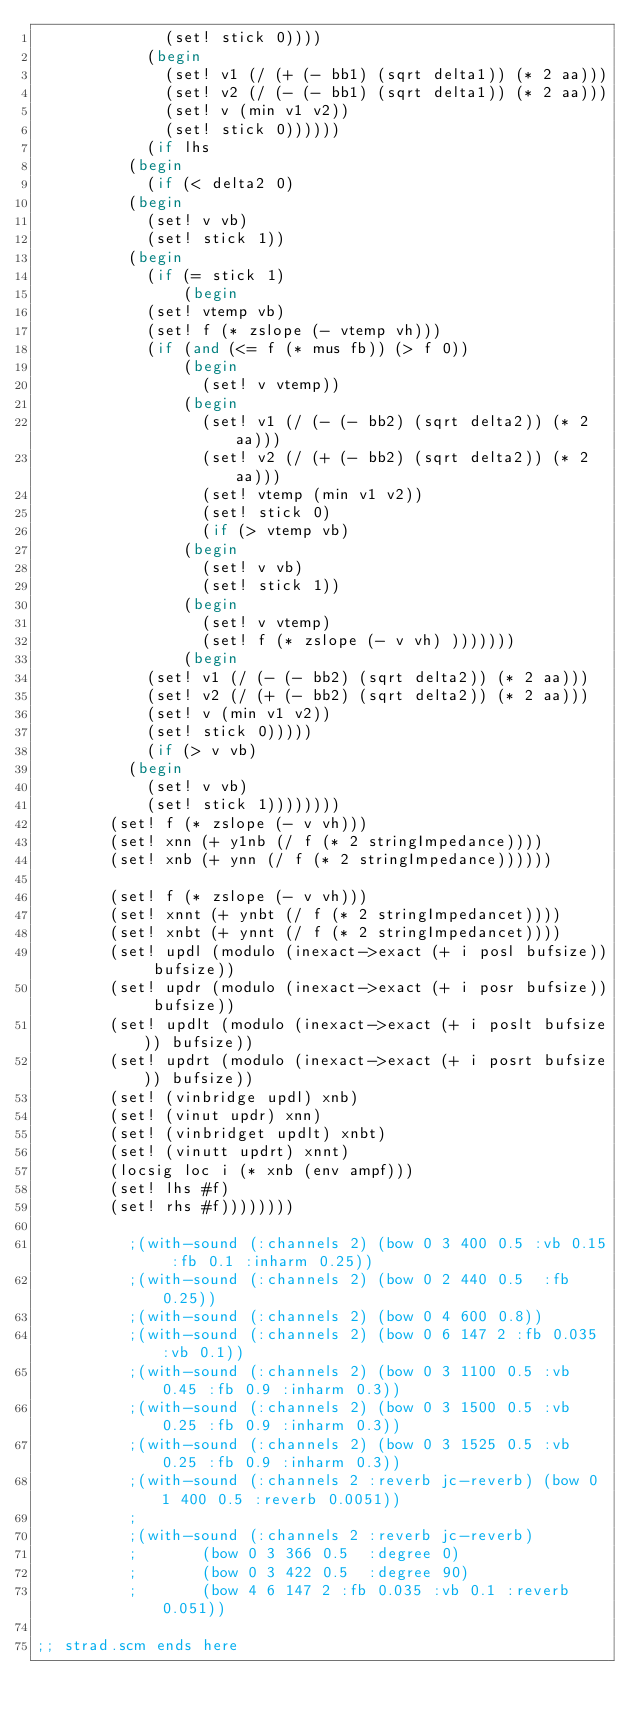<code> <loc_0><loc_0><loc_500><loc_500><_Scheme_>						  (set! stick 0))))
					  (begin
					    (set! v1 (/ (+ (- bb1) (sqrt delta1)) (* 2 aa)))
					    (set! v2 (/ (- (- bb1) (sqrt delta1)) (* 2 aa)))
					    (set! v (min v1 v2))
					    (set! stick 0))))))
			      (if lhs
				  (begin
				    (if (< delta2 0)
					(begin
					  (set! v vb)
					  (set! stick 1))
					(begin
					  (if (= stick 1)
					      (begin
						(set! vtemp vb)
						(set! f (* zslope (- vtemp vh)))
						(if (and (<= f (* mus fb)) (> f 0))
						    (begin
						      (set! v vtemp))
						    (begin
						      (set! v1 (/ (- (- bb2) (sqrt delta2)) (* 2 aa)))
						      (set! v2 (/ (+ (- bb2) (sqrt delta2)) (* 2 aa)))
						      (set! vtemp (min v1 v2))
						      (set! stick 0)
						      (if (> vtemp vb)
							  (begin
							    (set! v vb)
							    (set! stick 1))
							  (begin
							    (set! v vtemp)
							    (set! f (* zslope (- v vh) )))))))
					      (begin
						(set! v1 (/ (- (- bb2) (sqrt delta2)) (* 2 aa)))
						(set! v2 (/ (+ (- bb2) (sqrt delta2)) (* 2 aa)))
						(set! v (min v1 v2))
						(set! stick 0)))))
				    (if (> v vb)
					(begin
					  (set! v vb)
					  (set! stick 1))))))))
		    (set! f (* zslope (- v vh)))
		    (set! xnn (+ y1nb (/ f (* 2 stringImpedance))))
		    (set! xnb (+ ynn (/ f (* 2 stringImpedance))))))
	      
	      (set! f (* zslope (- v vh)))
	      (set! xnnt (+ ynbt (/ f (* 2 stringImpedancet))))
	      (set! xnbt (+ ynnt (/ f (* 2 stringImpedancet))))
	      (set! updl (modulo (inexact->exact (+ i posl bufsize)) bufsize))
	      (set! updr (modulo (inexact->exact (+ i posr bufsize)) bufsize))
	      (set! updlt (modulo (inexact->exact (+ i poslt bufsize)) bufsize))
	      (set! updrt (modulo (inexact->exact (+ i posrt bufsize)) bufsize))
	      (set! (vinbridge updl) xnb)
	      (set! (vinut updr) xnn)
	      (set! (vinbridget updlt) xnbt)
	      (set! (vinutt updrt) xnnt)
	      (locsig loc i (* xnb (env ampf)))
	      (set! lhs #f)
	      (set! rhs #f))))))))

					;(with-sound (:channels 2) (bow 0 3 400 0.5 :vb 0.15 :fb 0.1 :inharm 0.25))
					;(with-sound (:channels 2) (bow 0 2 440 0.5  :fb 0.25))
					;(with-sound (:channels 2) (bow 0 4 600 0.8))
					;(with-sound (:channels 2) (bow 0 6 147 2 :fb 0.035 :vb 0.1))
					;(with-sound (:channels 2) (bow 0 3 1100 0.5 :vb 0.45 :fb 0.9 :inharm 0.3))
					;(with-sound (:channels 2) (bow 0 3 1500 0.5 :vb 0.25 :fb 0.9 :inharm 0.3))
					;(with-sound (:channels 2) (bow 0 3 1525 0.5 :vb 0.25 :fb 0.9 :inharm 0.3))
					;(with-sound (:channels 2 :reverb jc-reverb) (bow 0 1 400 0.5 :reverb 0.0051))
					;
					;(with-sound (:channels 2 :reverb jc-reverb)
					; 	    (bow 0 3 366 0.5  :degree 0)
					; 	    (bow 0 3 422 0.5  :degree 90)
					; 	    (bow 4 6 147 2 :fb 0.035 :vb 0.1 :reverb 0.051))

;; strad.scm ends here
</code> 